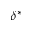Convert formula to latex. <formula><loc_0><loc_0><loc_500><loc_500>\delta ^ { * }</formula> 